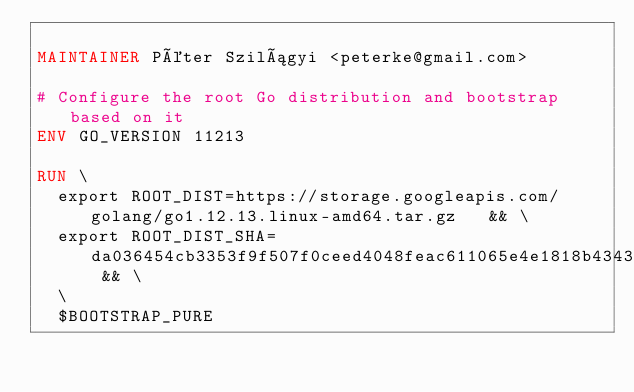<code> <loc_0><loc_0><loc_500><loc_500><_Dockerfile_>
MAINTAINER Péter Szilágyi <peterke@gmail.com>

# Configure the root Go distribution and bootstrap based on it
ENV GO_VERSION 11213

RUN \
  export ROOT_DIST=https://storage.googleapis.com/golang/go1.12.13.linux-amd64.tar.gz   && \
  export ROOT_DIST_SHA=da036454cb3353f9f507f0ceed4048feac611065e4e1818b434365eb32ac9bdc && \
  \
  $BOOTSTRAP_PURE
</code> 